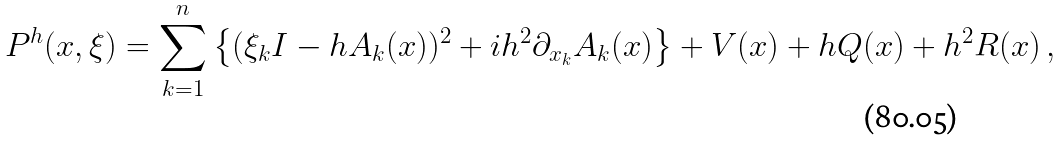Convert formula to latex. <formula><loc_0><loc_0><loc_500><loc_500>P ^ { h } ( x , \xi ) = \sum _ { k = 1 } ^ { n } \left \{ ( \xi _ { k } I - h A _ { k } ( x ) ) ^ { 2 } + i h ^ { 2 } \partial _ { x _ { k } } A _ { k } ( x ) \right \} + V ( x ) + h Q ( x ) + h ^ { 2 } R ( x ) \, ,</formula> 